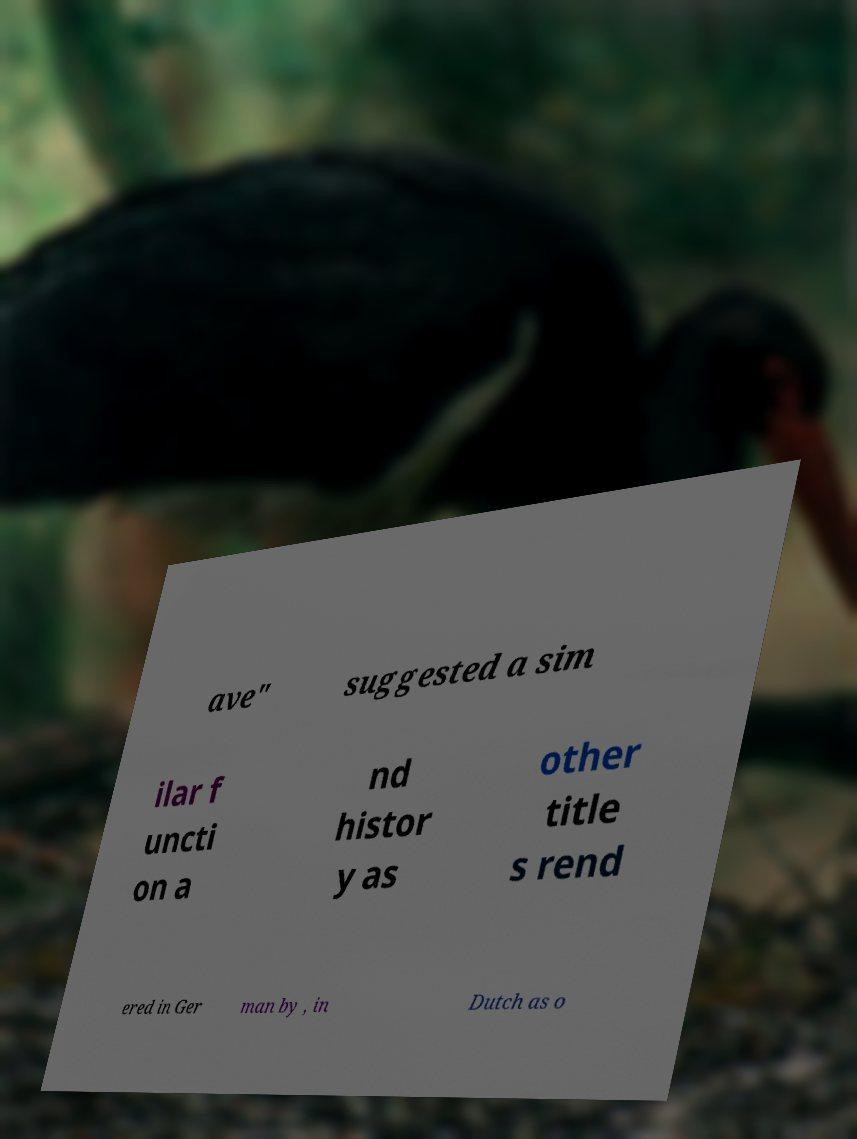Please identify and transcribe the text found in this image. ave" suggested a sim ilar f uncti on a nd histor y as other title s rend ered in Ger man by , in Dutch as o 